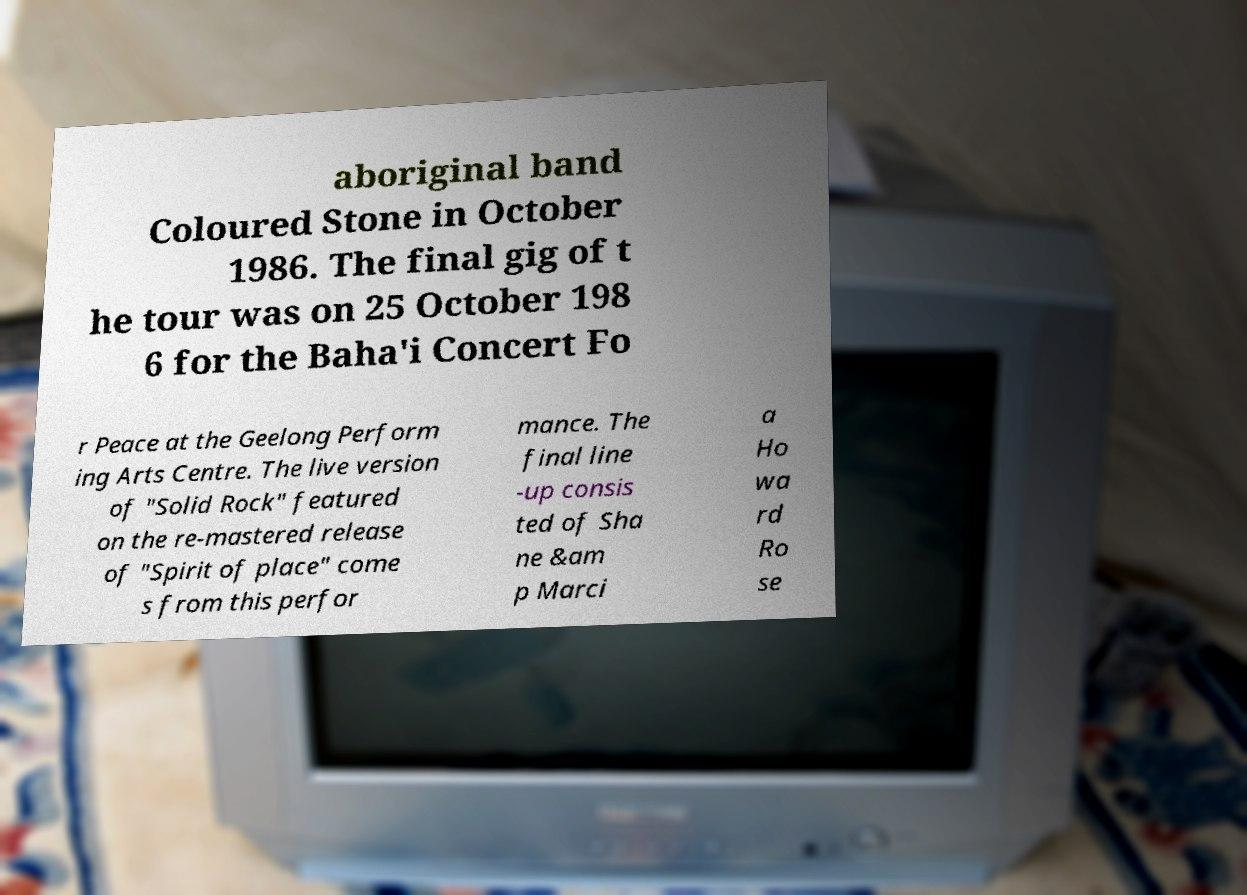Can you read and provide the text displayed in the image?This photo seems to have some interesting text. Can you extract and type it out for me? aboriginal band Coloured Stone in October 1986. The final gig of t he tour was on 25 October 198 6 for the Baha'i Concert Fo r Peace at the Geelong Perform ing Arts Centre. The live version of "Solid Rock" featured on the re-mastered release of "Spirit of place" come s from this perfor mance. The final line -up consis ted of Sha ne &am p Marci a Ho wa rd Ro se 